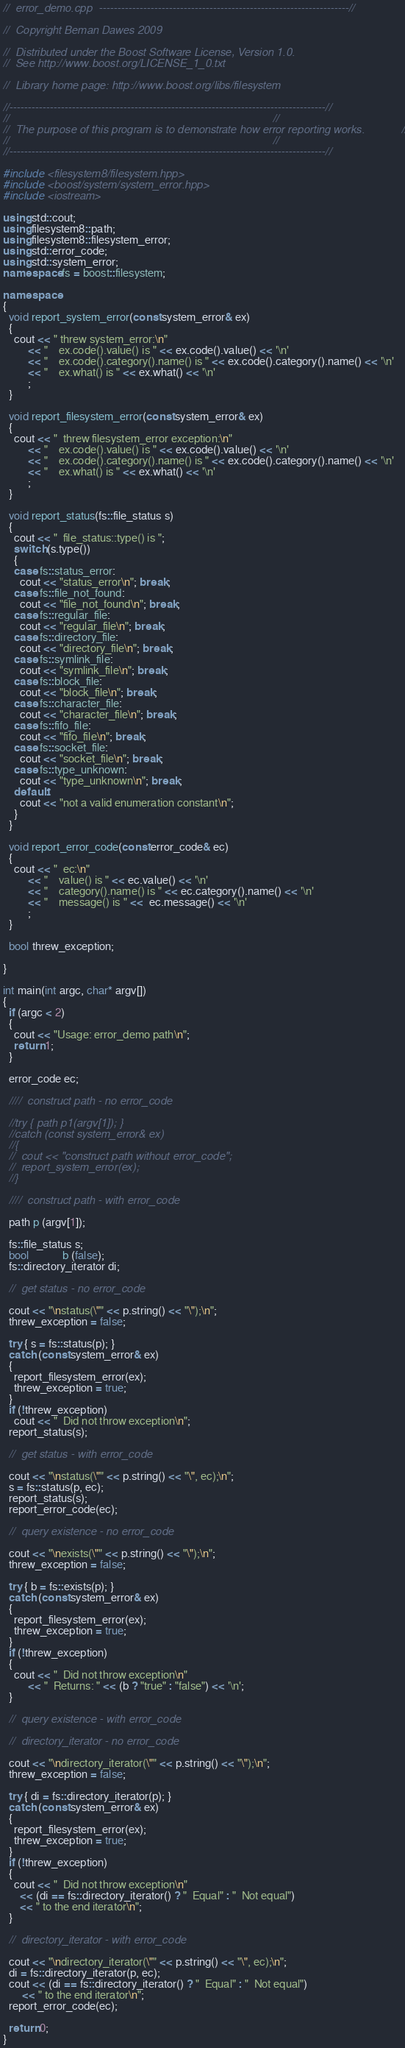<code> <loc_0><loc_0><loc_500><loc_500><_C++_>//  error_demo.cpp  --------------------------------------------------------------------//

//  Copyright Beman Dawes 2009

//  Distributed under the Boost Software License, Version 1.0.
//  See http://www.boost.org/LICENSE_1_0.txt

//  Library home page: http://www.boost.org/libs/filesystem

//--------------------------------------------------------------------------------------//
//                                                                                      //
//  The purpose of this program is to demonstrate how error reporting works.            //
//                                                                                      //
//--------------------------------------------------------------------------------------//

#include <filesystem8/filesystem.hpp>
#include <boost/system/system_error.hpp>
#include <iostream>

using std::cout;
using filesystem8::path;
using filesystem8::filesystem_error;
using std::error_code;
using std::system_error;
namespace fs = boost::filesystem;

namespace
{
  void report_system_error(const system_error& ex)
  {
    cout << " threw system_error:\n"
         << "    ex.code().value() is " << ex.code().value() << '\n'
         << "    ex.code().category().name() is " << ex.code().category().name() << '\n'
         << "    ex.what() is " << ex.what() << '\n'
         ;
  }

  void report_filesystem_error(const system_error& ex)
  {
    cout << "  threw filesystem_error exception:\n"
         << "    ex.code().value() is " << ex.code().value() << '\n'
         << "    ex.code().category().name() is " << ex.code().category().name() << '\n'
         << "    ex.what() is " << ex.what() << '\n'
         ;
  }

  void report_status(fs::file_status s)
  {
    cout << "  file_status::type() is ";
    switch (s.type())
    {
    case fs::status_error:
      cout << "status_error\n"; break;
    case fs::file_not_found:
      cout << "file_not_found\n"; break;
    case fs::regular_file:
      cout << "regular_file\n"; break;
    case fs::directory_file:
      cout << "directory_file\n"; break;
    case fs::symlink_file:
      cout << "symlink_file\n"; break;
    case fs::block_file:
      cout << "block_file\n"; break;
    case fs::character_file:
      cout << "character_file\n"; break;
    case fs::fifo_file:
      cout << "fifo_file\n"; break;
    case fs::socket_file:
      cout << "socket_file\n"; break;
    case fs::type_unknown:
      cout << "type_unknown\n"; break;
    default:
      cout << "not a valid enumeration constant\n";
    }
  }

  void report_error_code(const error_code& ec)
  {
    cout << "  ec:\n"
         << "    value() is " << ec.value() << '\n'
         << "    category().name() is " << ec.category().name() << '\n'
         << "    message() is " <<  ec.message() << '\n'
         ;
  }

  bool threw_exception;

}

int main(int argc, char* argv[])
{
  if (argc < 2)
  {
    cout << "Usage: error_demo path\n";
    return 1;
  }

  error_code ec;

  ////  construct path - no error_code

  //try { path p1(argv[1]); }
  //catch (const system_error& ex)
  //{
  //  cout << "construct path without error_code";
  //  report_system_error(ex);
  //}

  ////  construct path - with error_code

  path p (argv[1]);

  fs::file_status s;
  bool            b (false);
  fs::directory_iterator di;

  //  get status - no error_code

  cout << "\nstatus(\"" << p.string() << "\");\n";
  threw_exception = false;

  try { s = fs::status(p); }
  catch (const system_error& ex)
  {
    report_filesystem_error(ex);
    threw_exception = true;
  }
  if (!threw_exception)
    cout << "  Did not throw exception\n";
  report_status(s);

  //  get status - with error_code

  cout << "\nstatus(\"" << p.string() << "\", ec);\n";
  s = fs::status(p, ec);
  report_status(s);
  report_error_code(ec);

  //  query existence - no error_code

  cout << "\nexists(\"" << p.string() << "\");\n";
  threw_exception = false;

  try { b = fs::exists(p); }
  catch (const system_error& ex)
  {
    report_filesystem_error(ex);
    threw_exception = true;
  }
  if (!threw_exception)
  {
    cout << "  Did not throw exception\n"
         << "  Returns: " << (b ? "true" : "false") << '\n';
  }

  //  query existence - with error_code

  //  directory_iterator - no error_code

  cout << "\ndirectory_iterator(\"" << p.string() << "\");\n";
  threw_exception = false;

  try { di = fs::directory_iterator(p); }
  catch (const system_error& ex)
  {
    report_filesystem_error(ex);
    threw_exception = true;
  }
  if (!threw_exception)
  {
    cout << "  Did not throw exception\n"
      << (di == fs::directory_iterator() ? "  Equal" : "  Not equal")
      << " to the end iterator\n";
  }

  //  directory_iterator - with error_code

  cout << "\ndirectory_iterator(\"" << p.string() << "\", ec);\n";
  di = fs::directory_iterator(p, ec);
  cout << (di == fs::directory_iterator() ? "  Equal" : "  Not equal")
       << " to the end iterator\n";
  report_error_code(ec);

  return 0;
}
</code> 